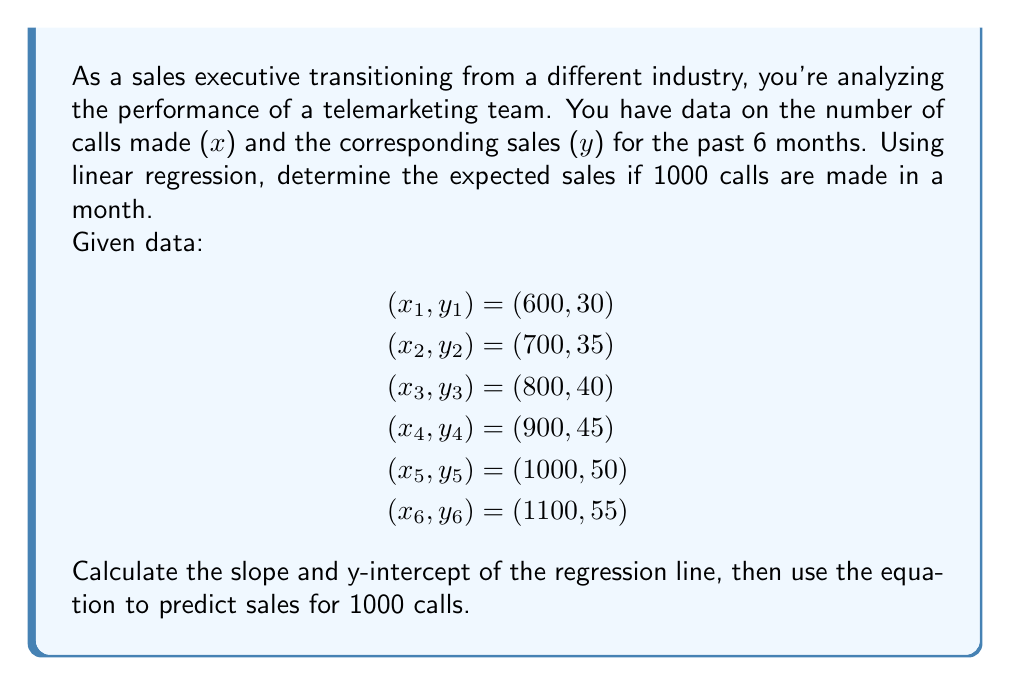Show me your answer to this math problem. To solve this problem, we'll use the linear regression equation:
$y = mx + b$, where $m$ is the slope and $b$ is the y-intercept.

Step 1: Calculate the means of x and y
$$\bar{x} = \frac{600 + 700 + 800 + 900 + 1000 + 1100}{6} = 850$$
$$\bar{y} = \frac{30 + 35 + 40 + 45 + 50 + 55}{6} = 42.5$$

Step 2: Calculate the slope (m)
We use the formula: $m = \frac{\sum(x_i - \bar{x})(y_i - \bar{y})}{\sum(x_i - \bar{x})^2}$

$$m = \frac{(-250)(-12.5) + (-150)(-7.5) + (-50)(-2.5) + (50)(2.5) + (150)(7.5) + (250)(12.5)}{(-250)^2 + (-150)^2 + (-50)^2 + (50)^2 + (150)^2 + (250)^2}$$

$$m = \frac{3125 + 1125 + 125 + 125 + 1125 + 3125}{62500 + 22500 + 2500 + 2500 + 22500 + 62500}$$

$$m = \frac{8750}{175000} = 0.05$$

Step 3: Calculate the y-intercept (b)
Using the formula: $b = \bar{y} - m\bar{x}$

$$b = 42.5 - (0.05)(850) = 0$$

Step 4: Write the regression equation
$y = 0.05x + 0$

Step 5: Predict sales for 1000 calls
$y = 0.05(1000) + 0 = 50$

Therefore, the expected sales for 1000 calls is 50 units.
Answer: The expected sales for 1000 calls is 50 units. 